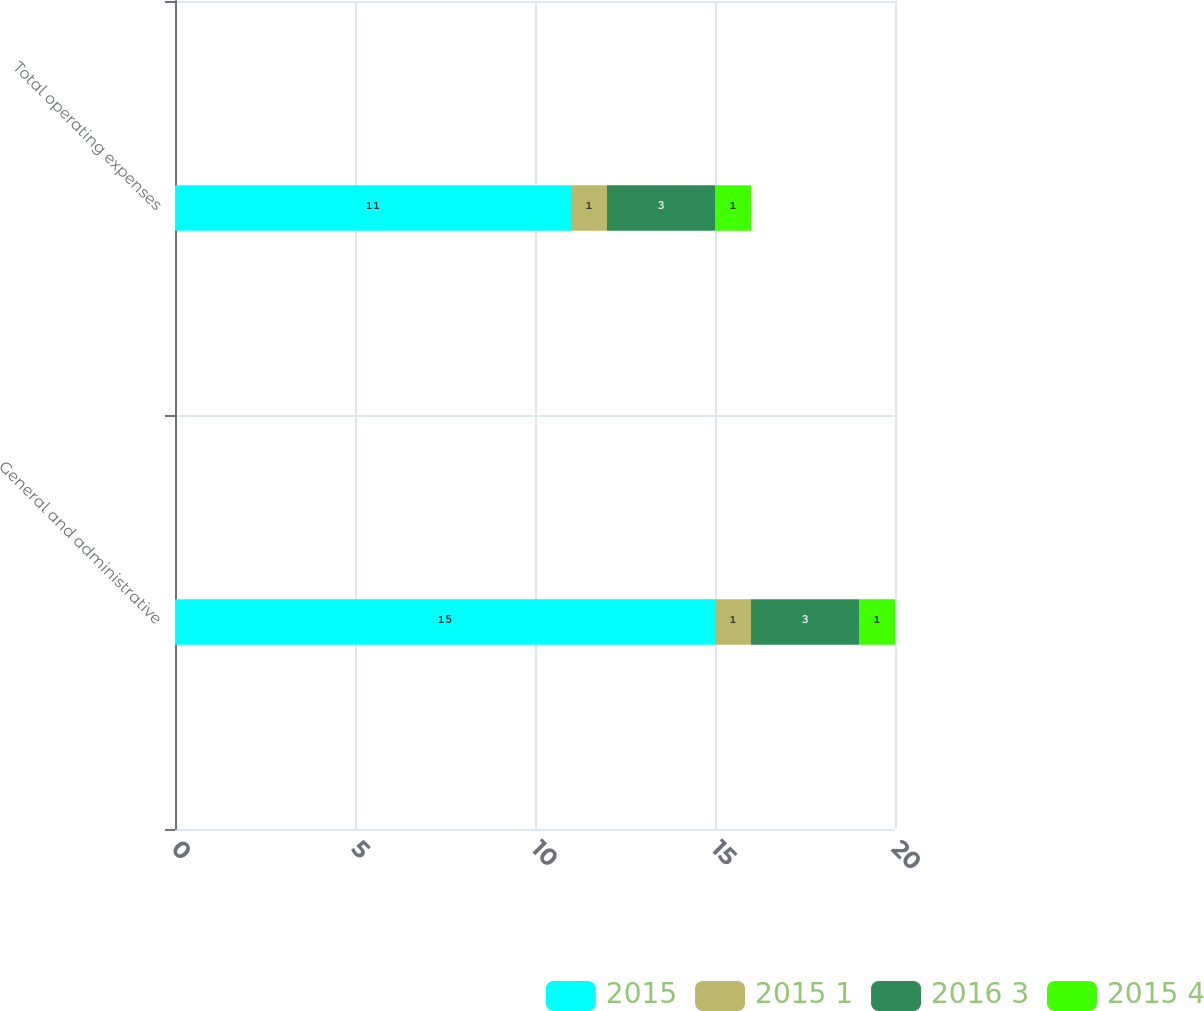Convert chart. <chart><loc_0><loc_0><loc_500><loc_500><stacked_bar_chart><ecel><fcel>General and administrative<fcel>Total operating expenses<nl><fcel>2015<fcel>15<fcel>11<nl><fcel>2015 1<fcel>1<fcel>1<nl><fcel>2016 3<fcel>3<fcel>3<nl><fcel>2015 4<fcel>1<fcel>1<nl></chart> 